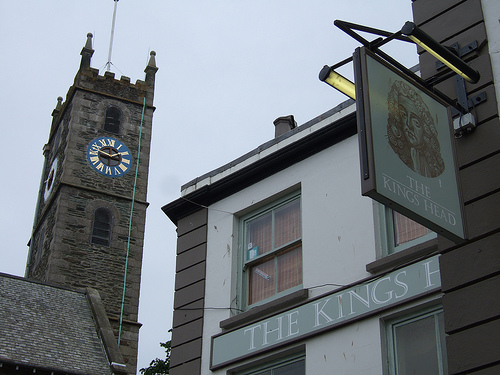Do you see clocks or towers in this image? Yes, the image features both a prominent tower with a blue clock, adding a historical and functional character to the scene. 